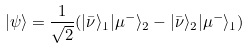<formula> <loc_0><loc_0><loc_500><loc_500>| \psi \rangle = \frac { 1 } { \sqrt { 2 } } ( | \bar { \nu } \rangle _ { 1 } | \mu ^ { - } \rangle _ { 2 } - | \bar { \nu } \rangle _ { 2 } | \mu ^ { - } \rangle _ { 1 } )</formula> 